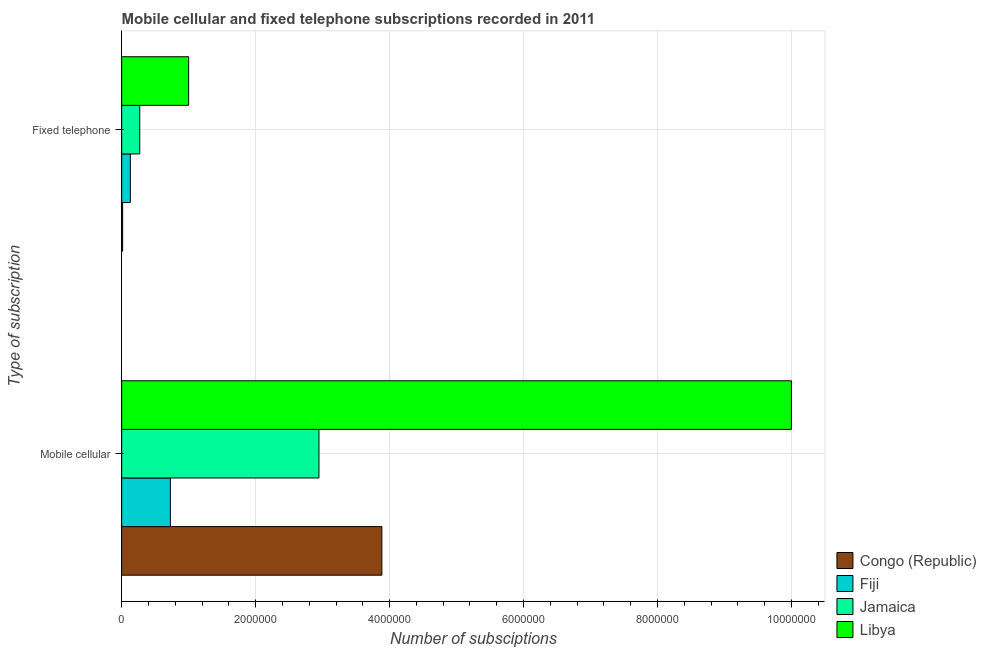Are the number of bars per tick equal to the number of legend labels?
Your response must be concise. Yes. How many bars are there on the 2nd tick from the top?
Keep it short and to the point. 4. What is the label of the 2nd group of bars from the top?
Ensure brevity in your answer.  Mobile cellular. What is the number of fixed telephone subscriptions in Libya?
Provide a succinct answer. 1.00e+06. Across all countries, what is the maximum number of fixed telephone subscriptions?
Provide a succinct answer. 1.00e+06. Across all countries, what is the minimum number of mobile cellular subscriptions?
Offer a very short reply. 7.27e+05. In which country was the number of mobile cellular subscriptions maximum?
Ensure brevity in your answer.  Libya. In which country was the number of mobile cellular subscriptions minimum?
Your response must be concise. Fiji. What is the total number of fixed telephone subscriptions in the graph?
Provide a succinct answer. 1.41e+06. What is the difference between the number of mobile cellular subscriptions in Libya and that in Congo (Republic)?
Offer a terse response. 6.12e+06. What is the difference between the number of mobile cellular subscriptions in Libya and the number of fixed telephone subscriptions in Jamaica?
Provide a short and direct response. 9.73e+06. What is the average number of mobile cellular subscriptions per country?
Offer a very short reply. 4.39e+06. What is the difference between the number of fixed telephone subscriptions and number of mobile cellular subscriptions in Jamaica?
Ensure brevity in your answer.  -2.68e+06. What is the ratio of the number of fixed telephone subscriptions in Fiji to that in Libya?
Give a very brief answer. 0.13. What does the 4th bar from the top in Mobile cellular represents?
Your answer should be very brief. Congo (Republic). What does the 3rd bar from the bottom in Mobile cellular represents?
Your answer should be very brief. Jamaica. How many bars are there?
Your response must be concise. 8. Are all the bars in the graph horizontal?
Offer a terse response. Yes. What is the difference between two consecutive major ticks on the X-axis?
Ensure brevity in your answer.  2.00e+06. Does the graph contain grids?
Ensure brevity in your answer.  Yes. How many legend labels are there?
Offer a terse response. 4. How are the legend labels stacked?
Your response must be concise. Vertical. What is the title of the graph?
Offer a terse response. Mobile cellular and fixed telephone subscriptions recorded in 2011. What is the label or title of the X-axis?
Offer a terse response. Number of subsciptions. What is the label or title of the Y-axis?
Provide a succinct answer. Type of subscription. What is the Number of subsciptions in Congo (Republic) in Mobile cellular?
Provide a short and direct response. 3.88e+06. What is the Number of subsciptions in Fiji in Mobile cellular?
Make the answer very short. 7.27e+05. What is the Number of subsciptions in Jamaica in Mobile cellular?
Offer a very short reply. 2.95e+06. What is the Number of subsciptions of Congo (Republic) in Fixed telephone?
Give a very brief answer. 1.42e+04. What is the Number of subsciptions of Fiji in Fixed telephone?
Give a very brief answer. 1.30e+05. What is the Number of subsciptions in Jamaica in Fixed telephone?
Make the answer very short. 2.70e+05. What is the Number of subsciptions of Libya in Fixed telephone?
Your response must be concise. 1.00e+06. Across all Type of subscription, what is the maximum Number of subsciptions of Congo (Republic)?
Keep it short and to the point. 3.88e+06. Across all Type of subscription, what is the maximum Number of subsciptions of Fiji?
Offer a very short reply. 7.27e+05. Across all Type of subscription, what is the maximum Number of subsciptions in Jamaica?
Ensure brevity in your answer.  2.95e+06. Across all Type of subscription, what is the maximum Number of subsciptions of Libya?
Your response must be concise. 1.00e+07. Across all Type of subscription, what is the minimum Number of subsciptions of Congo (Republic)?
Keep it short and to the point. 1.42e+04. Across all Type of subscription, what is the minimum Number of subsciptions in Fiji?
Your answer should be very brief. 1.30e+05. Across all Type of subscription, what is the minimum Number of subsciptions in Jamaica?
Offer a very short reply. 2.70e+05. What is the total Number of subsciptions in Congo (Republic) in the graph?
Your answer should be compact. 3.90e+06. What is the total Number of subsciptions in Fiji in the graph?
Provide a short and direct response. 8.57e+05. What is the total Number of subsciptions of Jamaica in the graph?
Offer a terse response. 3.22e+06. What is the total Number of subsciptions of Libya in the graph?
Your answer should be very brief. 1.10e+07. What is the difference between the Number of subsciptions in Congo (Republic) in Mobile cellular and that in Fixed telephone?
Provide a short and direct response. 3.87e+06. What is the difference between the Number of subsciptions of Fiji in Mobile cellular and that in Fixed telephone?
Your answer should be compact. 5.97e+05. What is the difference between the Number of subsciptions in Jamaica in Mobile cellular and that in Fixed telephone?
Keep it short and to the point. 2.68e+06. What is the difference between the Number of subsciptions of Libya in Mobile cellular and that in Fixed telephone?
Ensure brevity in your answer.  9.00e+06. What is the difference between the Number of subsciptions in Congo (Republic) in Mobile cellular and the Number of subsciptions in Fiji in Fixed telephone?
Provide a succinct answer. 3.75e+06. What is the difference between the Number of subsciptions in Congo (Republic) in Mobile cellular and the Number of subsciptions in Jamaica in Fixed telephone?
Ensure brevity in your answer.  3.61e+06. What is the difference between the Number of subsciptions of Congo (Republic) in Mobile cellular and the Number of subsciptions of Libya in Fixed telephone?
Give a very brief answer. 2.88e+06. What is the difference between the Number of subsciptions in Fiji in Mobile cellular and the Number of subsciptions in Jamaica in Fixed telephone?
Offer a very short reply. 4.57e+05. What is the difference between the Number of subsciptions of Fiji in Mobile cellular and the Number of subsciptions of Libya in Fixed telephone?
Your response must be concise. -2.73e+05. What is the difference between the Number of subsciptions of Jamaica in Mobile cellular and the Number of subsciptions of Libya in Fixed telephone?
Your answer should be compact. 1.95e+06. What is the average Number of subsciptions in Congo (Republic) per Type of subscription?
Provide a succinct answer. 1.95e+06. What is the average Number of subsciptions of Fiji per Type of subscription?
Offer a very short reply. 4.28e+05. What is the average Number of subsciptions of Jamaica per Type of subscription?
Ensure brevity in your answer.  1.61e+06. What is the average Number of subsciptions in Libya per Type of subscription?
Make the answer very short. 5.50e+06. What is the difference between the Number of subsciptions in Congo (Republic) and Number of subsciptions in Fiji in Mobile cellular?
Your response must be concise. 3.16e+06. What is the difference between the Number of subsciptions in Congo (Republic) and Number of subsciptions in Jamaica in Mobile cellular?
Ensure brevity in your answer.  9.39e+05. What is the difference between the Number of subsciptions of Congo (Republic) and Number of subsciptions of Libya in Mobile cellular?
Give a very brief answer. -6.12e+06. What is the difference between the Number of subsciptions of Fiji and Number of subsciptions of Jamaica in Mobile cellular?
Provide a short and direct response. -2.22e+06. What is the difference between the Number of subsciptions of Fiji and Number of subsciptions of Libya in Mobile cellular?
Keep it short and to the point. -9.27e+06. What is the difference between the Number of subsciptions in Jamaica and Number of subsciptions in Libya in Mobile cellular?
Provide a succinct answer. -7.05e+06. What is the difference between the Number of subsciptions of Congo (Republic) and Number of subsciptions of Fiji in Fixed telephone?
Offer a terse response. -1.16e+05. What is the difference between the Number of subsciptions in Congo (Republic) and Number of subsciptions in Jamaica in Fixed telephone?
Your response must be concise. -2.56e+05. What is the difference between the Number of subsciptions of Congo (Republic) and Number of subsciptions of Libya in Fixed telephone?
Ensure brevity in your answer.  -9.86e+05. What is the difference between the Number of subsciptions of Fiji and Number of subsciptions of Jamaica in Fixed telephone?
Provide a short and direct response. -1.40e+05. What is the difference between the Number of subsciptions of Fiji and Number of subsciptions of Libya in Fixed telephone?
Your response must be concise. -8.70e+05. What is the difference between the Number of subsciptions in Jamaica and Number of subsciptions in Libya in Fixed telephone?
Provide a succinct answer. -7.30e+05. What is the ratio of the Number of subsciptions in Congo (Republic) in Mobile cellular to that in Fixed telephone?
Give a very brief answer. 273.57. What is the ratio of the Number of subsciptions of Fiji in Mobile cellular to that in Fixed telephone?
Keep it short and to the point. 5.6. What is the ratio of the Number of subsciptions of Jamaica in Mobile cellular to that in Fixed telephone?
Offer a terse response. 10.91. What is the ratio of the Number of subsciptions in Libya in Mobile cellular to that in Fixed telephone?
Give a very brief answer. 10. What is the difference between the highest and the second highest Number of subsciptions of Congo (Republic)?
Give a very brief answer. 3.87e+06. What is the difference between the highest and the second highest Number of subsciptions in Fiji?
Your response must be concise. 5.97e+05. What is the difference between the highest and the second highest Number of subsciptions of Jamaica?
Provide a succinct answer. 2.68e+06. What is the difference between the highest and the second highest Number of subsciptions of Libya?
Offer a terse response. 9.00e+06. What is the difference between the highest and the lowest Number of subsciptions of Congo (Republic)?
Your response must be concise. 3.87e+06. What is the difference between the highest and the lowest Number of subsciptions in Fiji?
Offer a terse response. 5.97e+05. What is the difference between the highest and the lowest Number of subsciptions of Jamaica?
Offer a very short reply. 2.68e+06. What is the difference between the highest and the lowest Number of subsciptions of Libya?
Provide a succinct answer. 9.00e+06. 